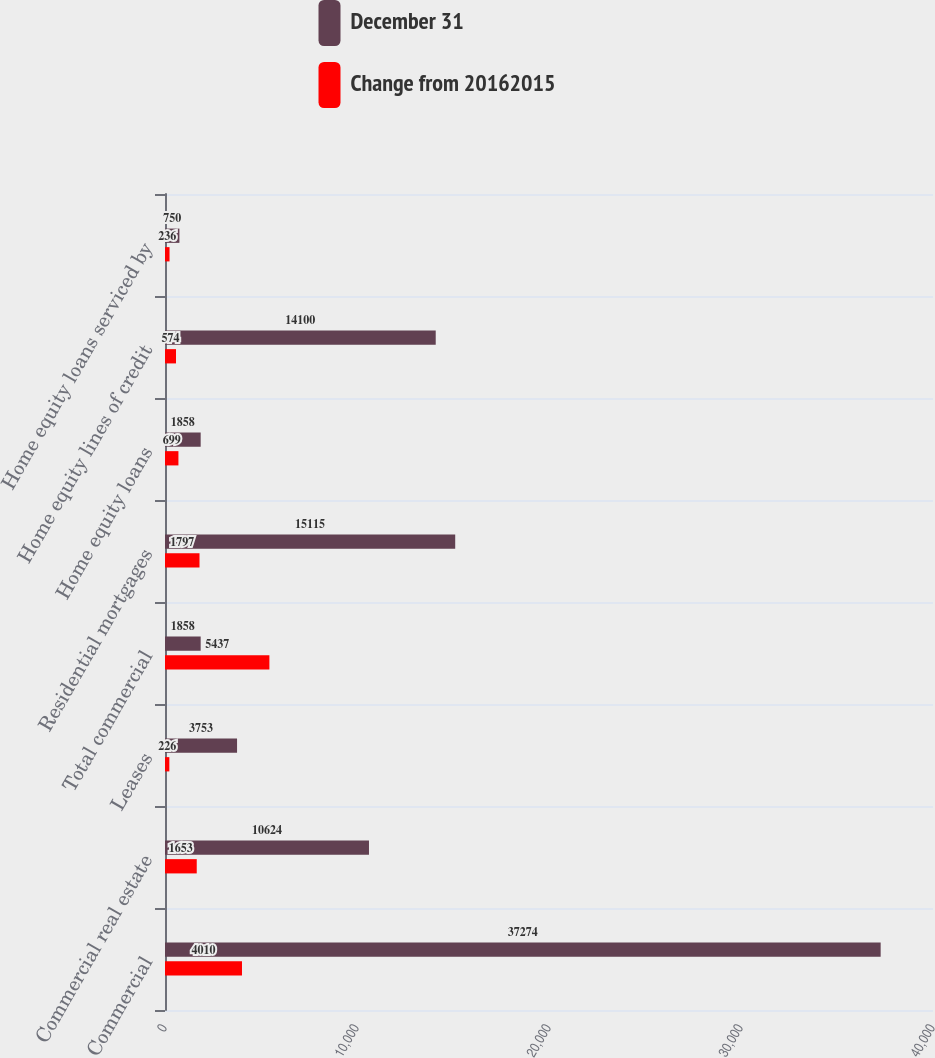<chart> <loc_0><loc_0><loc_500><loc_500><stacked_bar_chart><ecel><fcel>Commercial<fcel>Commercial real estate<fcel>Leases<fcel>Total commercial<fcel>Residential mortgages<fcel>Home equity loans<fcel>Home equity lines of credit<fcel>Home equity loans serviced by<nl><fcel>December 31<fcel>37274<fcel>10624<fcel>3753<fcel>1858<fcel>15115<fcel>1858<fcel>14100<fcel>750<nl><fcel>Change from 20162015<fcel>4010<fcel>1653<fcel>226<fcel>5437<fcel>1797<fcel>699<fcel>574<fcel>236<nl></chart> 